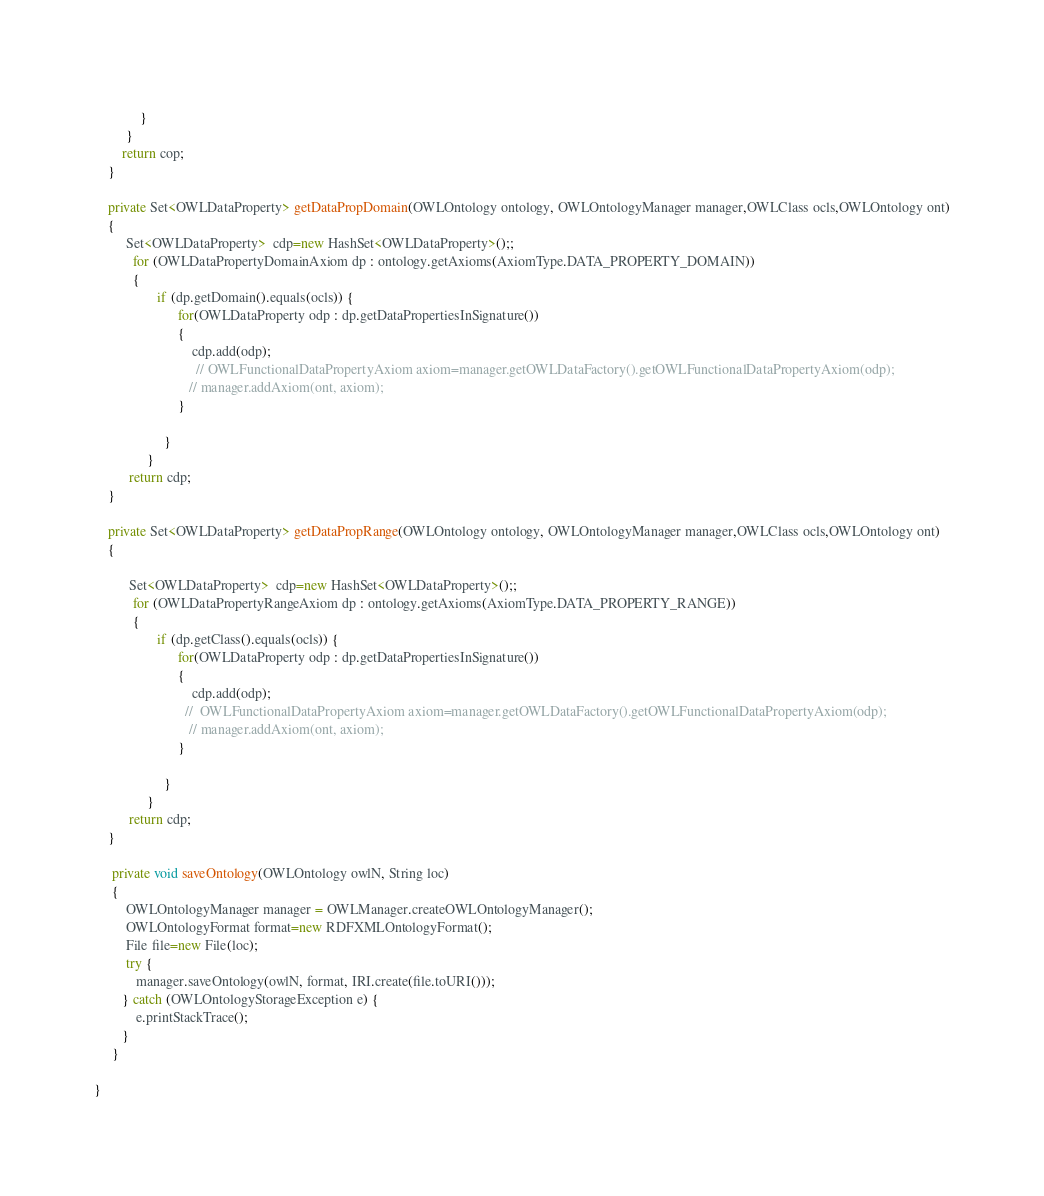Convert code to text. <code><loc_0><loc_0><loc_500><loc_500><_Java_>	             
	         }
	     }
	    return cop;
	}

	private Set<OWLDataProperty> getDataPropDomain(OWLOntology ontology, OWLOntologyManager manager,OWLClass ocls,OWLOntology ont)
	{
		 Set<OWLDataProperty>  cdp=new HashSet<OWLDataProperty>();;
	       for (OWLDataPropertyDomainAxiom dp : ontology.getAxioms(AxiomType.DATA_PROPERTY_DOMAIN))
	       {
		          if (dp.getDomain().equals(ocls)) {   
		                for(OWLDataProperty odp : dp.getDataPropertiesInSignature())
		                {
		                    cdp.add(odp); 
		                     // OWLFunctionalDataPropertyAxiom axiom=manager.getOWLDataFactory().getOWLFunctionalDataPropertyAxiom(odp);
		               	   // manager.addAxiom(ont, axiom);
		                }
		                
		            }
		       }
	      return cdp;
	}

	private Set<OWLDataProperty> getDataPropRange(OWLOntology ontology, OWLOntologyManager manager,OWLClass ocls,OWLOntology ont)
	{

	   	  Set<OWLDataProperty>  cdp=new HashSet<OWLDataProperty>();;
	       for (OWLDataPropertyRangeAxiom dp : ontology.getAxioms(AxiomType.DATA_PROPERTY_RANGE))
	       {
		          if (dp.getClass().equals(ocls)) {    
		                for(OWLDataProperty odp : dp.getDataPropertiesInSignature())
		                {
		                    cdp.add(odp); 
		                  //  OWLFunctionalDataPropertyAxiom axiom=manager.getOWLDataFactory().getOWLFunctionalDataPropertyAxiom(odp);
		               	   // manager.addAxiom(ont, axiom);
		                }
		                
		            }
		       }
	      return cdp;
	}

	 private void saveOntology(OWLOntology owlN, String loc)
	 {
		 OWLOntologyManager manager = OWLManager.createOWLOntologyManager();
		 OWLOntologyFormat format=new RDFXMLOntologyFormat();
		 File file=new File(loc);
		 try {
			manager.saveOntology(owlN, format, IRI.create(file.toURI()));
		} catch (OWLOntologyStorageException e) {
			e.printStackTrace();
		}
	 }

}
</code> 